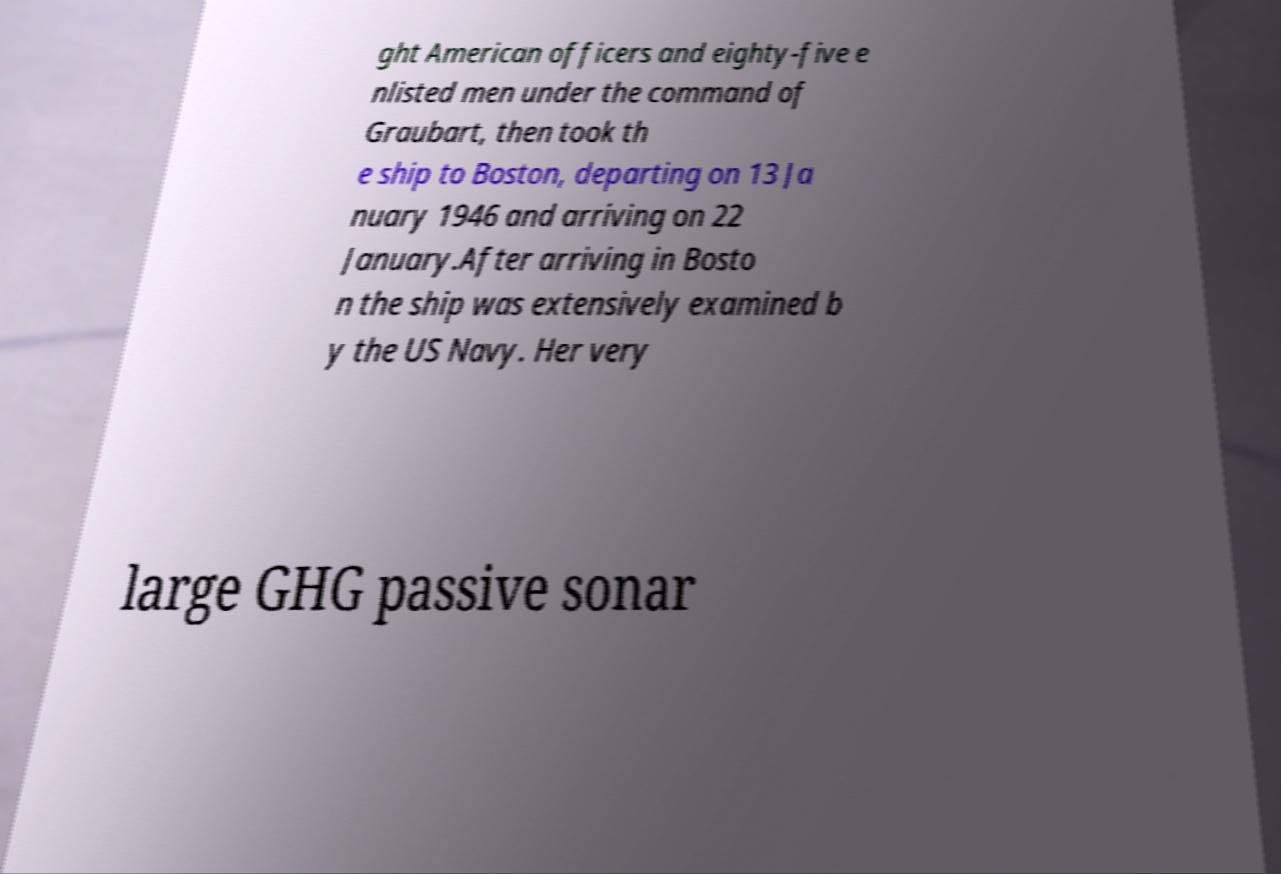Please identify and transcribe the text found in this image. ght American officers and eighty-five e nlisted men under the command of Graubart, then took th e ship to Boston, departing on 13 Ja nuary 1946 and arriving on 22 January.After arriving in Bosto n the ship was extensively examined b y the US Navy. Her very large GHG passive sonar 